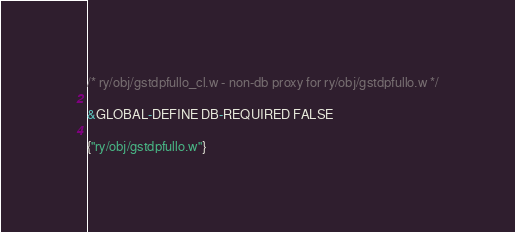Convert code to text. <code><loc_0><loc_0><loc_500><loc_500><_C_>/* ry/obj/gstdpfullo_cl.w - non-db proxy for ry/obj/gstdpfullo.w */

&GLOBAL-DEFINE DB-REQUIRED FALSE

{"ry/obj/gstdpfullo.w"}
</code> 